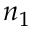Convert formula to latex. <formula><loc_0><loc_0><loc_500><loc_500>n _ { 1 }</formula> 